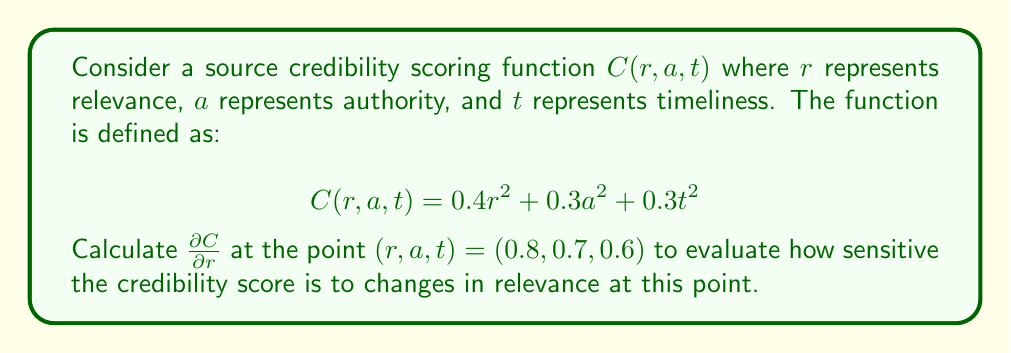Can you answer this question? To find $\frac{\partial C}{\partial r}$ at the point $(0.8, 0.7, 0.6)$, we follow these steps:

1) First, we need to find the partial derivative of $C$ with respect to $r$:

   $\frac{\partial C}{\partial r} = \frac{\partial}{\partial r}(0.4r^2 + 0.3a^2 + 0.3t^2)$

2) The terms not involving $r$ become zero when differentiated:

   $\frac{\partial C}{\partial r} = \frac{\partial}{\partial r}(0.4r^2) + 0 + 0$

3) Apply the power rule of differentiation:

   $\frac{\partial C}{\partial r} = 0.4 \cdot 2r = 0.8r$

4) Now that we have the partial derivative, we can evaluate it at the point $(0.8, 0.7, 0.6)$:

   $\frac{\partial C}{\partial r}|_{(0.8, 0.7, 0.6)} = 0.8(0.8) = 0.64$

This value represents the rate of change of the credibility score with respect to relevance at the given point. It indicates that for small changes in relevance near $r = 0.8$, the credibility score will change at approximately 0.64 times that rate.
Answer: $\frac{\partial C}{\partial r}|_{(0.8, 0.7, 0.6)} = 0.64$ 